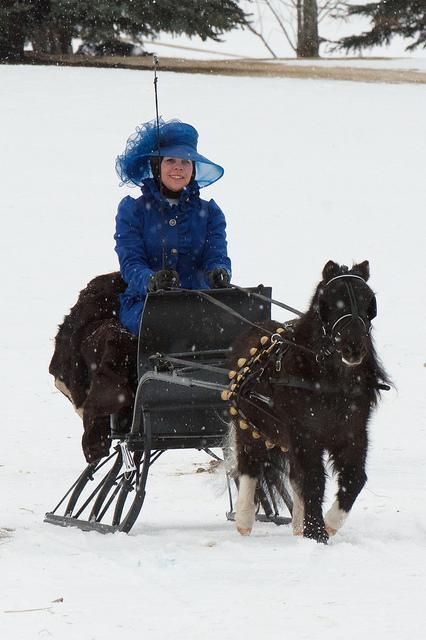How many dogs are playing in the ocean?
Give a very brief answer. 0. 